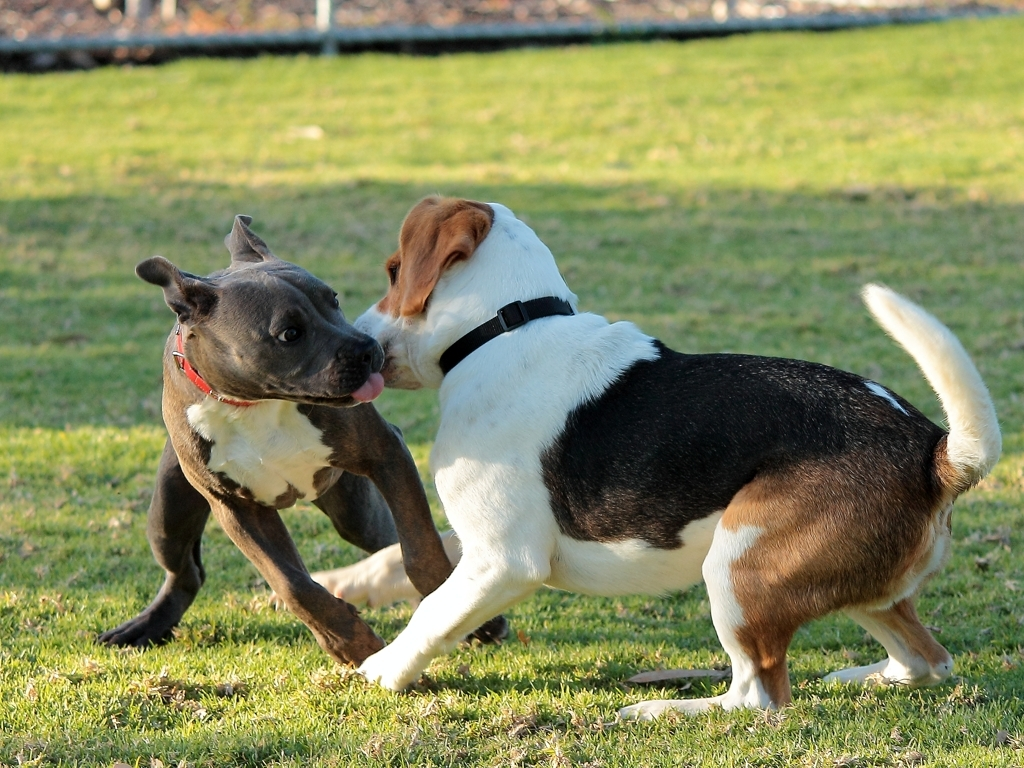How does the environment contribute to the scene captured in the image? The environment here adds a serene backdrop to the dynamic activity of the dogs. The open grassy area provides a safe and spacious playground for the dogs to run and engage with each other without restriction. The soft lighting of what appears to be late afternoon or early evening contributes to the overall pleasant ambience of the setting. 